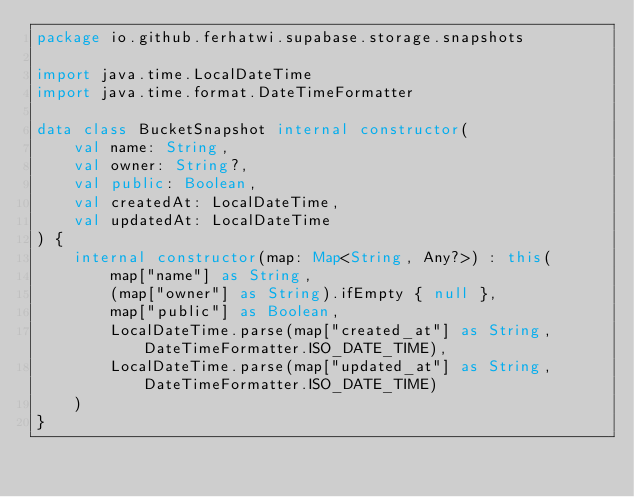Convert code to text. <code><loc_0><loc_0><loc_500><loc_500><_Kotlin_>package io.github.ferhatwi.supabase.storage.snapshots

import java.time.LocalDateTime
import java.time.format.DateTimeFormatter

data class BucketSnapshot internal constructor(
    val name: String,
    val owner: String?,
    val public: Boolean,
    val createdAt: LocalDateTime,
    val updatedAt: LocalDateTime
) {
    internal constructor(map: Map<String, Any?>) : this(
        map["name"] as String,
        (map["owner"] as String).ifEmpty { null },
        map["public"] as Boolean,
        LocalDateTime.parse(map["created_at"] as String, DateTimeFormatter.ISO_DATE_TIME),
        LocalDateTime.parse(map["updated_at"] as String, DateTimeFormatter.ISO_DATE_TIME)
    )
}</code> 